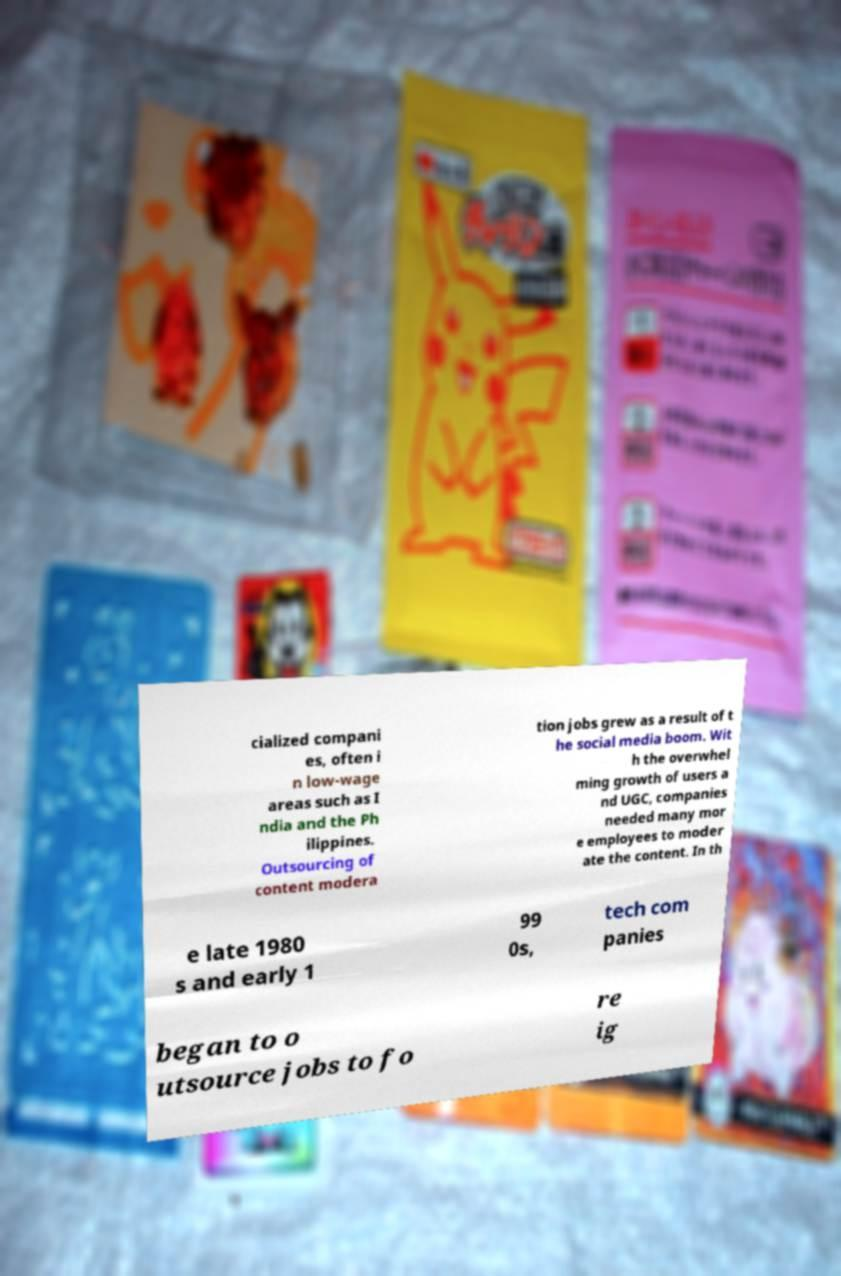Could you assist in decoding the text presented in this image and type it out clearly? cialized compani es, often i n low-wage areas such as I ndia and the Ph ilippines. Outsourcing of content modera tion jobs grew as a result of t he social media boom. Wit h the overwhel ming growth of users a nd UGC, companies needed many mor e employees to moder ate the content. In th e late 1980 s and early 1 99 0s, tech com panies began to o utsource jobs to fo re ig 